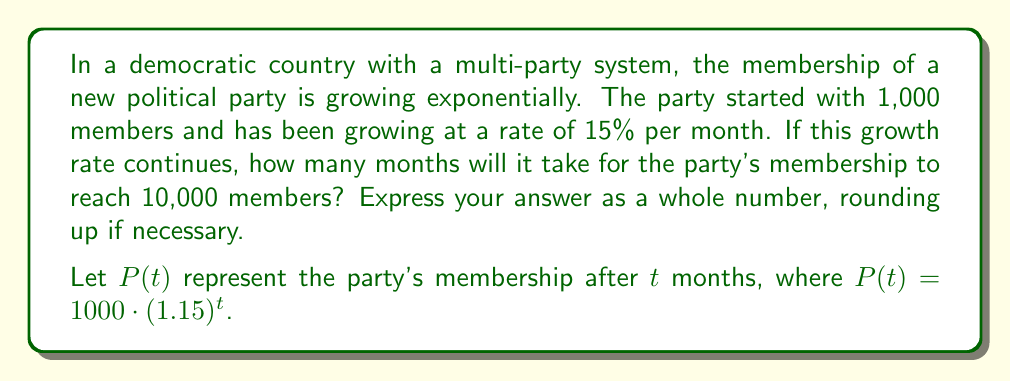Show me your answer to this math problem. To solve this problem, we need to use the exponential growth formula and solve for time $t$. Let's break it down step-by-step:

1) We're given the exponential growth function:
   $P(t) = 1000 \cdot (1.15)^t$

2) We want to find $t$ when $P(t) = 10000$. So, let's set up the equation:
   $10000 = 1000 \cdot (1.15)^t$

3) Divide both sides by 1000:
   $10 = (1.15)^t$

4) Now, we need to solve for $t$. We can do this by taking the natural logarithm of both sides:
   $\ln(10) = \ln((1.15)^t)$

5) Using the logarithm property $\ln(a^b) = b\ln(a)$, we get:
   $\ln(10) = t \cdot \ln(1.15)$

6) Now we can solve for $t$:
   $t = \frac{\ln(10)}{\ln(1.15)}$

7) Using a calculator or computer, we can evaluate this:
   $t \approx 16.27$ months

8) Since we need to express the answer as a whole number of months and round up, our final answer is 17 months.

This problem demonstrates how exponential growth can be applied to model the rapid expansion of political party membership in a democratic system, reflecting the importance of public participation and the potential for new parties to gain significant support over time.
Answer: 17 months 